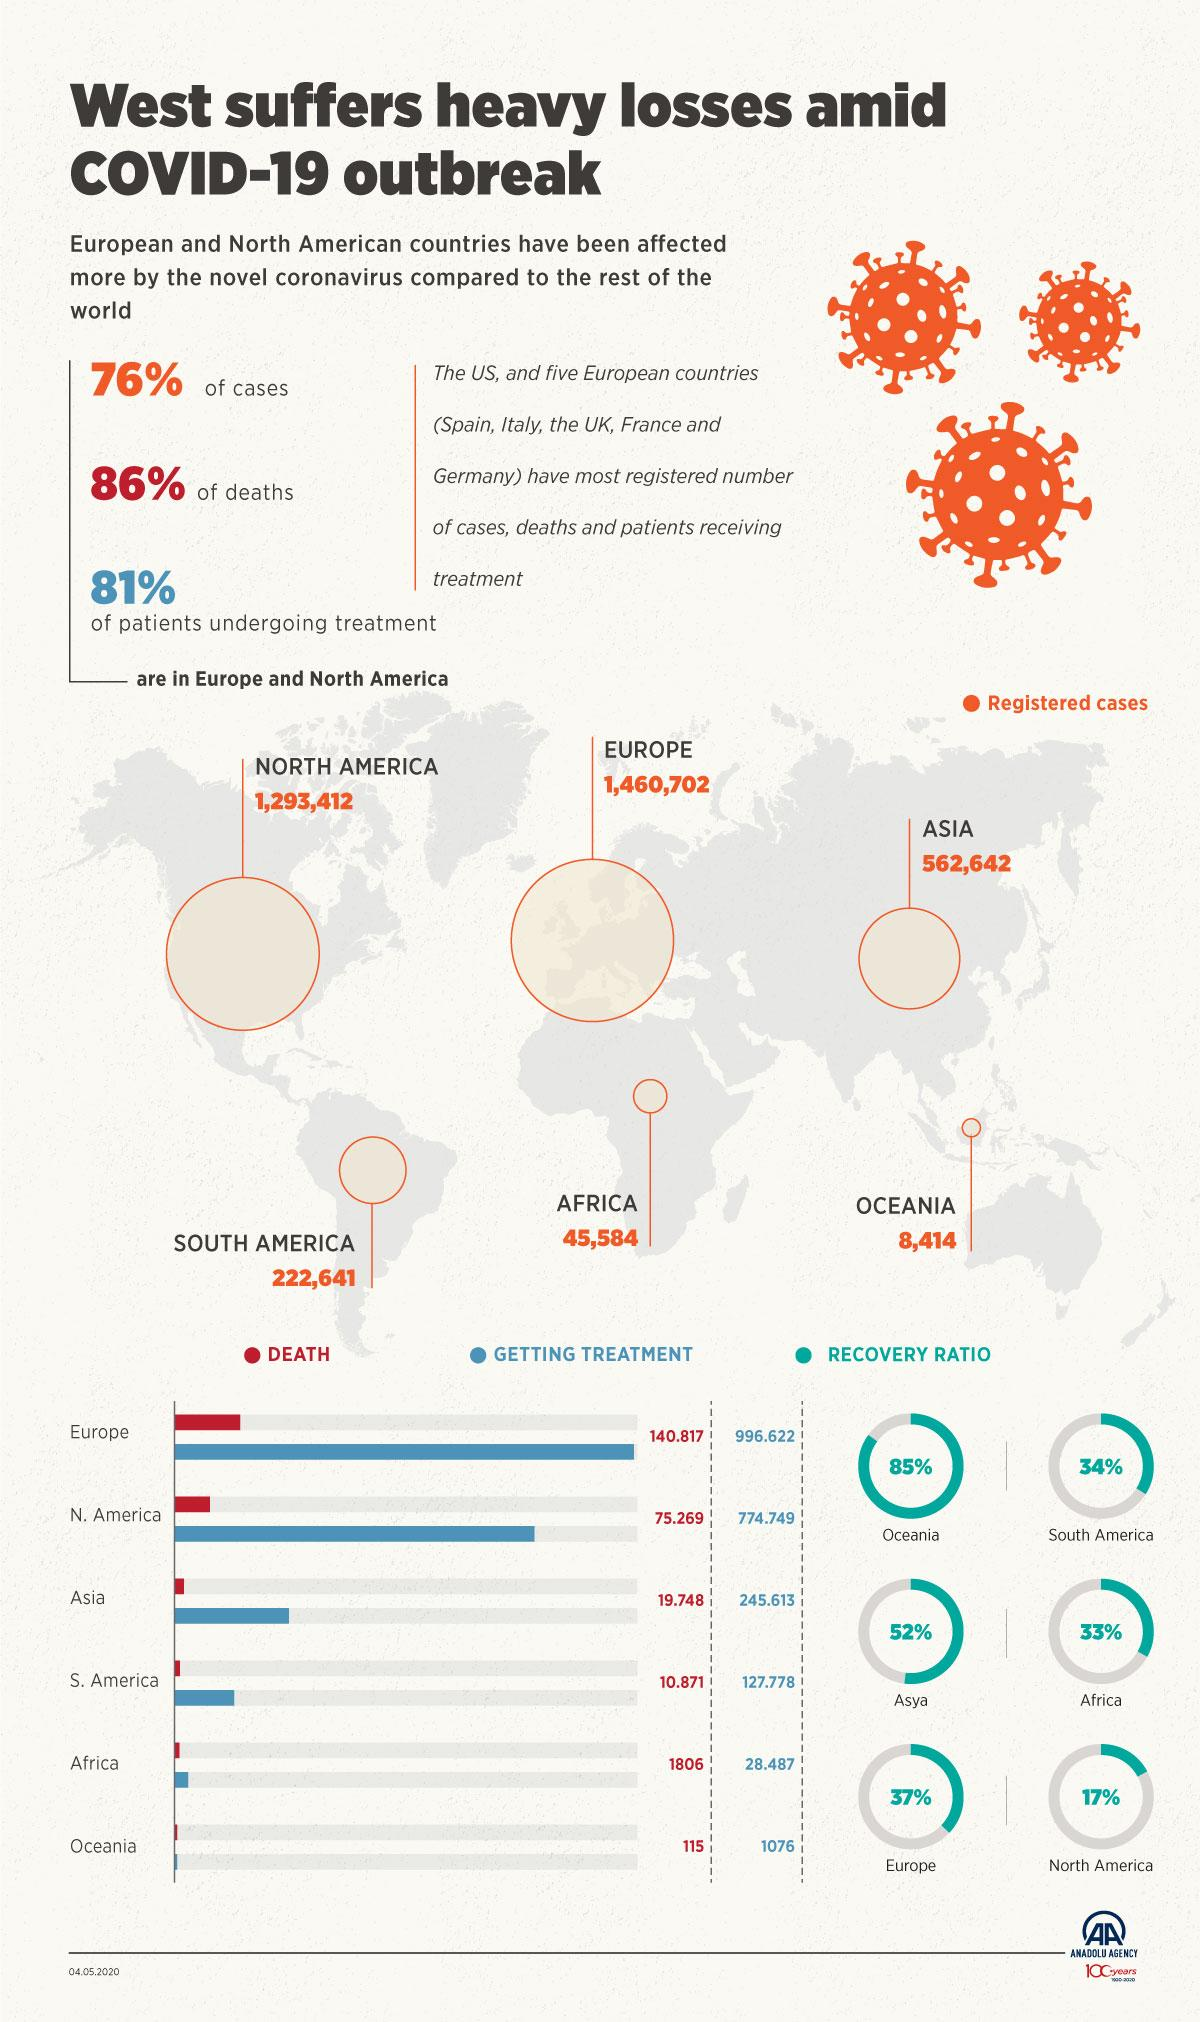Highlight a few significant elements in this photo. The vast majority of COVID-19 cases, which total 76%, are reported in Europe and North America. According to the data, Asia has more registered cases than Africa. Europe has reported more than 1.4 million cases of COVID-19, making it the continent with the highest number of registered cases. According to reported data, the majority of COVID-19 deaths, approximately 86%, have occurred in Europe and North America. Oceania is the continent that has less than 10,000 registered cases of COVID-19. 